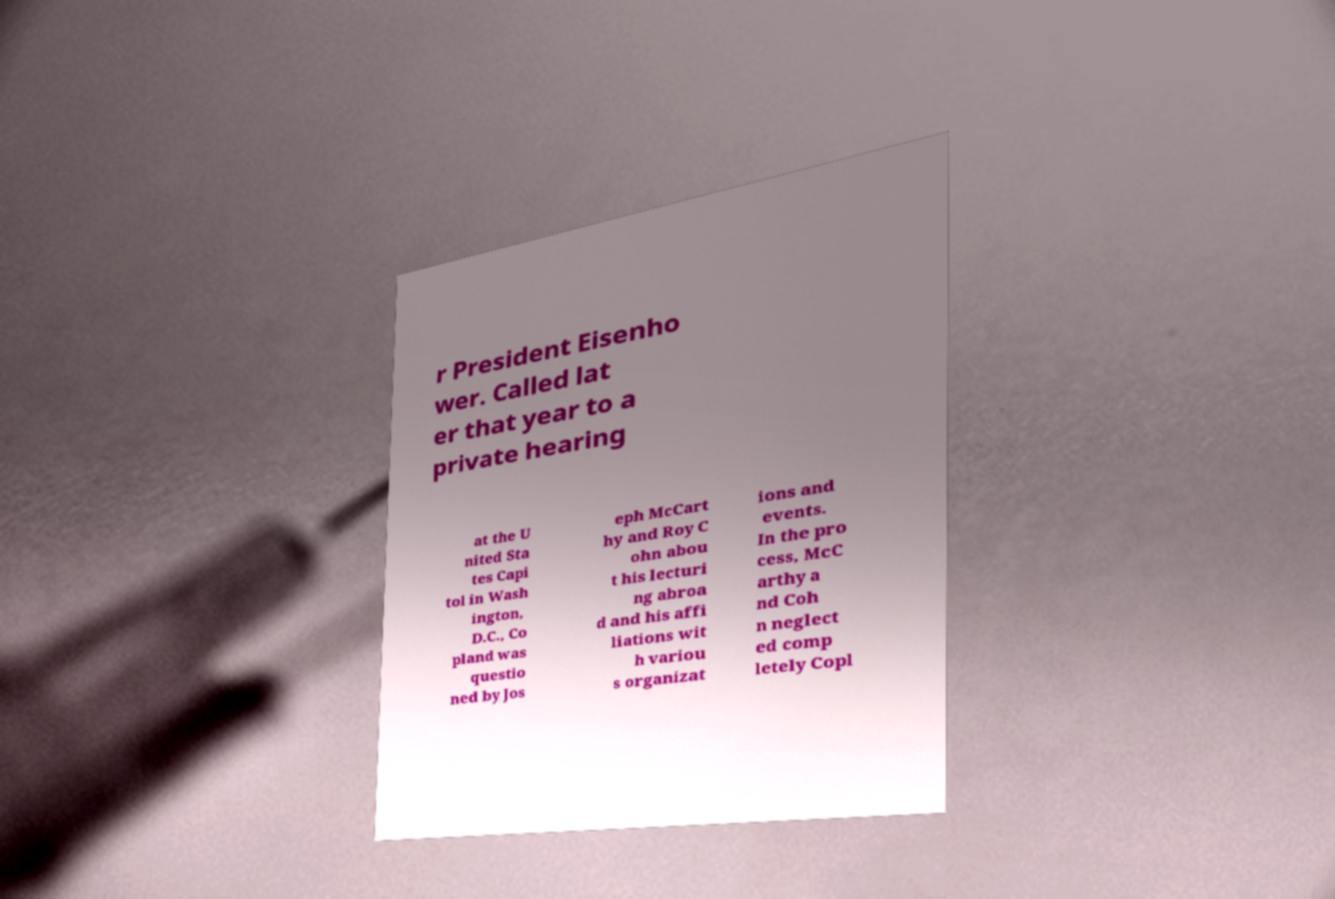Please identify and transcribe the text found in this image. r President Eisenho wer. Called lat er that year to a private hearing at the U nited Sta tes Capi tol in Wash ington, D.C., Co pland was questio ned by Jos eph McCart hy and Roy C ohn abou t his lecturi ng abroa d and his affi liations wit h variou s organizat ions and events. In the pro cess, McC arthy a nd Coh n neglect ed comp letely Copl 